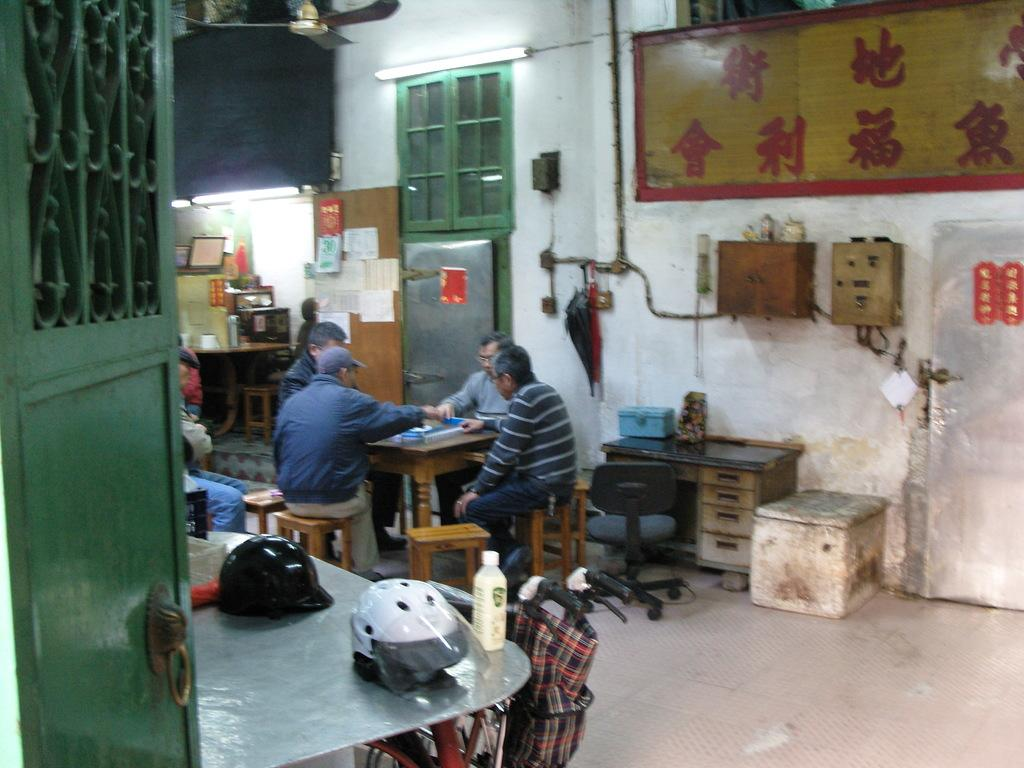How many people are in the image? There is a group of people in the image. What are the people doing in the image? The people are sitting on stools. What is in front of the people? There is a table in front of the people. What objects are placed on the table? Helmets are placed on the table. What type of cheese is being served on the table in the image? There is no cheese present in the image; the objects on the table are helmets. How many frogs are sitting on the stools with the people in the image? There are no frogs present in the image; the people sitting on the stools are human. 